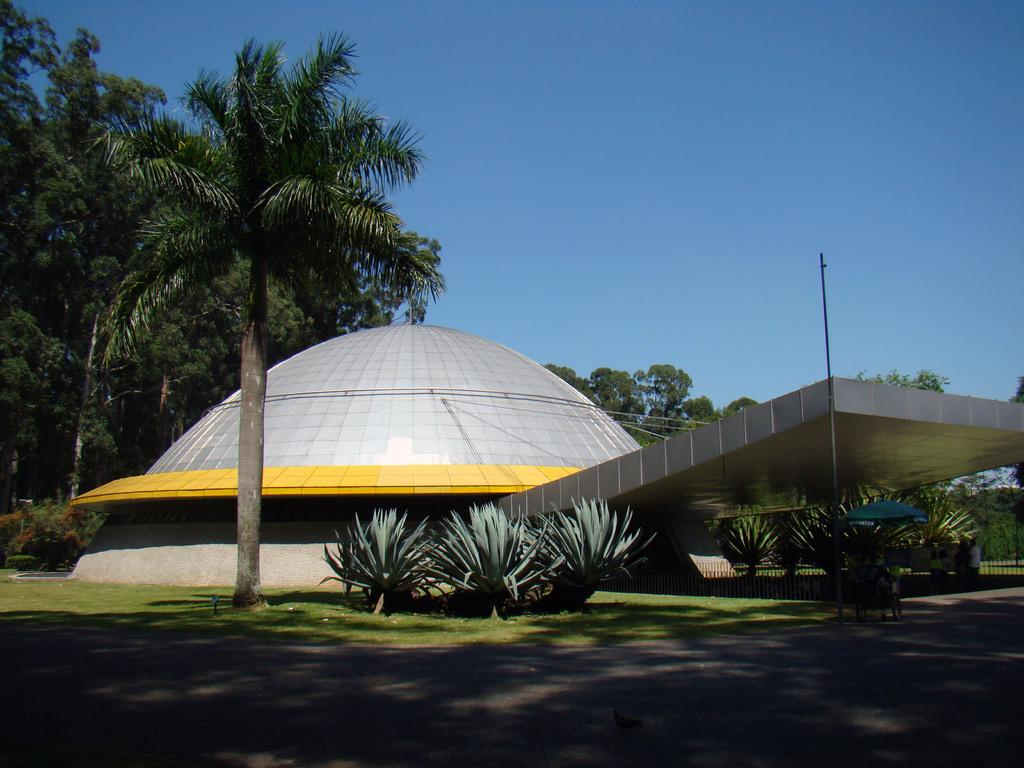What type of structure is featured in the picture? There is an architecture building in the picture. What type of vegetation can be seen in the picture? There are shrubs, grass, and trees in the picture. What color is the sky in the background of the picture? The sky is blue in the background of the picture. What type of card is being used to prop up the root in the picture? There is no card or root present in the picture; it features an architecture building, shrubs, grass, trees, and a blue sky. 